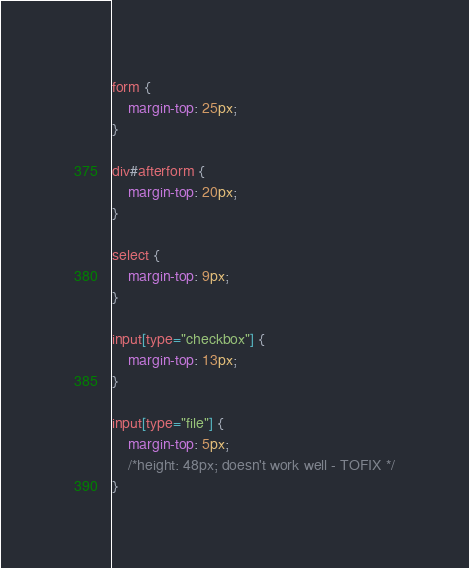Convert code to text. <code><loc_0><loc_0><loc_500><loc_500><_CSS_>form {
	margin-top: 25px;
}

div#afterform {
	margin-top: 20px;
}

select {
	margin-top: 9px;
}

input[type="checkbox"] {
	margin-top: 13px;
}

input[type="file"] {
	margin-top: 5px;
	/*height: 48px; doesn't work well - TOFIX */
}
</code> 